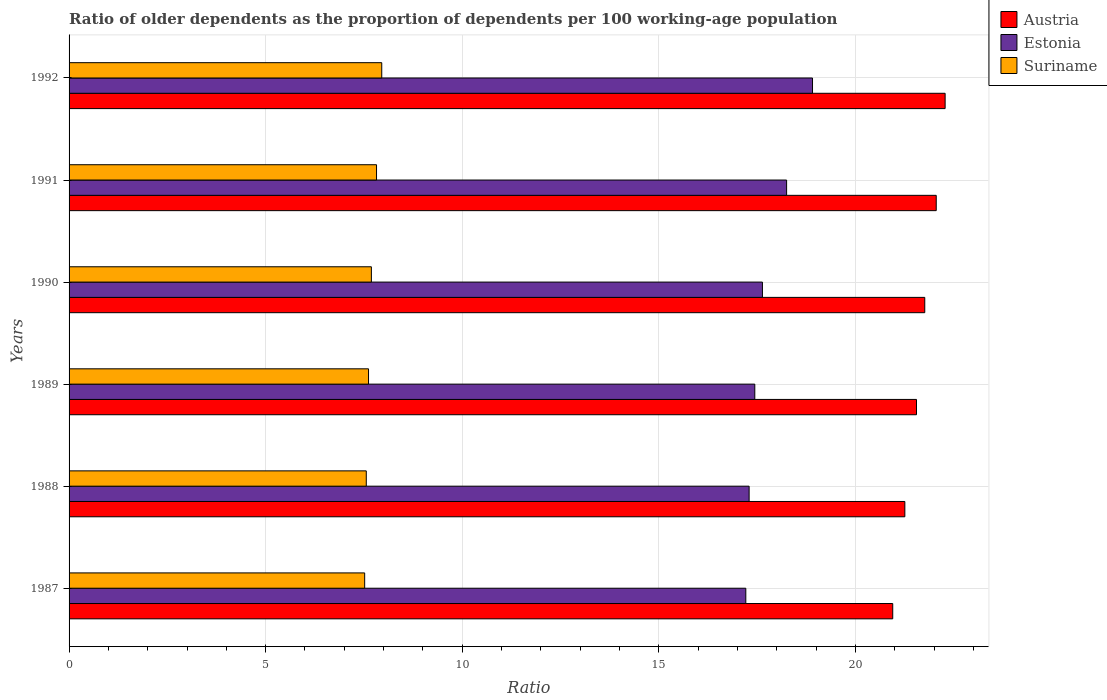How many different coloured bars are there?
Provide a short and direct response. 3. How many groups of bars are there?
Offer a terse response. 6. Are the number of bars per tick equal to the number of legend labels?
Ensure brevity in your answer.  Yes. How many bars are there on the 1st tick from the bottom?
Provide a short and direct response. 3. What is the label of the 1st group of bars from the top?
Make the answer very short. 1992. What is the age dependency ratio(old) in Suriname in 1989?
Ensure brevity in your answer.  7.62. Across all years, what is the maximum age dependency ratio(old) in Suriname?
Provide a succinct answer. 7.95. Across all years, what is the minimum age dependency ratio(old) in Estonia?
Keep it short and to the point. 17.21. What is the total age dependency ratio(old) in Estonia in the graph?
Your answer should be very brief. 106.75. What is the difference between the age dependency ratio(old) in Suriname in 1988 and that in 1991?
Keep it short and to the point. -0.26. What is the difference between the age dependency ratio(old) in Austria in 1988 and the age dependency ratio(old) in Estonia in 1991?
Offer a very short reply. 3.01. What is the average age dependency ratio(old) in Austria per year?
Your answer should be compact. 21.64. In the year 1991, what is the difference between the age dependency ratio(old) in Estonia and age dependency ratio(old) in Austria?
Keep it short and to the point. -3.81. In how many years, is the age dependency ratio(old) in Austria greater than 22 ?
Your answer should be compact. 2. What is the ratio of the age dependency ratio(old) in Suriname in 1991 to that in 1992?
Your answer should be compact. 0.98. Is the age dependency ratio(old) in Austria in 1987 less than that in 1988?
Keep it short and to the point. Yes. Is the difference between the age dependency ratio(old) in Estonia in 1987 and 1990 greater than the difference between the age dependency ratio(old) in Austria in 1987 and 1990?
Offer a very short reply. Yes. What is the difference between the highest and the second highest age dependency ratio(old) in Austria?
Your answer should be very brief. 0.23. What is the difference between the highest and the lowest age dependency ratio(old) in Estonia?
Offer a terse response. 1.7. Is the sum of the age dependency ratio(old) in Suriname in 1987 and 1988 greater than the maximum age dependency ratio(old) in Estonia across all years?
Your answer should be compact. No. What does the 1st bar from the top in 1987 represents?
Make the answer very short. Suriname. What does the 2nd bar from the bottom in 1989 represents?
Offer a terse response. Estonia. What is the difference between two consecutive major ticks on the X-axis?
Offer a terse response. 5. Are the values on the major ticks of X-axis written in scientific E-notation?
Make the answer very short. No. Does the graph contain grids?
Keep it short and to the point. Yes. How many legend labels are there?
Provide a short and direct response. 3. How are the legend labels stacked?
Your response must be concise. Vertical. What is the title of the graph?
Keep it short and to the point. Ratio of older dependents as the proportion of dependents per 100 working-age population. Does "Cayman Islands" appear as one of the legend labels in the graph?
Your response must be concise. No. What is the label or title of the X-axis?
Provide a short and direct response. Ratio. What is the Ratio of Austria in 1987?
Your answer should be very brief. 20.95. What is the Ratio in Estonia in 1987?
Provide a short and direct response. 17.21. What is the Ratio of Suriname in 1987?
Your answer should be very brief. 7.52. What is the Ratio of Austria in 1988?
Keep it short and to the point. 21.26. What is the Ratio in Estonia in 1988?
Offer a terse response. 17.3. What is the Ratio in Suriname in 1988?
Give a very brief answer. 7.56. What is the Ratio in Austria in 1989?
Give a very brief answer. 21.55. What is the Ratio in Estonia in 1989?
Make the answer very short. 17.44. What is the Ratio of Suriname in 1989?
Give a very brief answer. 7.62. What is the Ratio of Austria in 1990?
Provide a succinct answer. 21.76. What is the Ratio in Estonia in 1990?
Provide a succinct answer. 17.64. What is the Ratio of Suriname in 1990?
Offer a very short reply. 7.69. What is the Ratio in Austria in 1991?
Provide a short and direct response. 22.06. What is the Ratio of Estonia in 1991?
Provide a succinct answer. 18.25. What is the Ratio of Suriname in 1991?
Ensure brevity in your answer.  7.82. What is the Ratio of Austria in 1992?
Your response must be concise. 22.28. What is the Ratio in Estonia in 1992?
Provide a succinct answer. 18.91. What is the Ratio in Suriname in 1992?
Offer a terse response. 7.95. Across all years, what is the maximum Ratio in Austria?
Keep it short and to the point. 22.28. Across all years, what is the maximum Ratio in Estonia?
Make the answer very short. 18.91. Across all years, what is the maximum Ratio in Suriname?
Keep it short and to the point. 7.95. Across all years, what is the minimum Ratio of Austria?
Offer a very short reply. 20.95. Across all years, what is the minimum Ratio of Estonia?
Provide a short and direct response. 17.21. Across all years, what is the minimum Ratio of Suriname?
Your answer should be very brief. 7.52. What is the total Ratio of Austria in the graph?
Provide a succinct answer. 129.87. What is the total Ratio in Estonia in the graph?
Keep it short and to the point. 106.75. What is the total Ratio in Suriname in the graph?
Your answer should be very brief. 46.16. What is the difference between the Ratio of Austria in 1987 and that in 1988?
Make the answer very short. -0.31. What is the difference between the Ratio in Estonia in 1987 and that in 1988?
Make the answer very short. -0.08. What is the difference between the Ratio of Suriname in 1987 and that in 1988?
Offer a terse response. -0.04. What is the difference between the Ratio in Austria in 1987 and that in 1989?
Provide a short and direct response. -0.6. What is the difference between the Ratio in Estonia in 1987 and that in 1989?
Make the answer very short. -0.23. What is the difference between the Ratio of Suriname in 1987 and that in 1989?
Offer a terse response. -0.1. What is the difference between the Ratio in Austria in 1987 and that in 1990?
Ensure brevity in your answer.  -0.81. What is the difference between the Ratio in Estonia in 1987 and that in 1990?
Your answer should be very brief. -0.42. What is the difference between the Ratio in Suriname in 1987 and that in 1990?
Offer a very short reply. -0.17. What is the difference between the Ratio of Austria in 1987 and that in 1991?
Your answer should be compact. -1.11. What is the difference between the Ratio in Estonia in 1987 and that in 1991?
Provide a short and direct response. -1.04. What is the difference between the Ratio in Suriname in 1987 and that in 1991?
Offer a terse response. -0.3. What is the difference between the Ratio in Austria in 1987 and that in 1992?
Make the answer very short. -1.33. What is the difference between the Ratio in Estonia in 1987 and that in 1992?
Ensure brevity in your answer.  -1.7. What is the difference between the Ratio in Suriname in 1987 and that in 1992?
Your answer should be very brief. -0.43. What is the difference between the Ratio of Austria in 1988 and that in 1989?
Make the answer very short. -0.3. What is the difference between the Ratio in Estonia in 1988 and that in 1989?
Keep it short and to the point. -0.14. What is the difference between the Ratio in Suriname in 1988 and that in 1989?
Your answer should be very brief. -0.06. What is the difference between the Ratio of Austria in 1988 and that in 1990?
Keep it short and to the point. -0.51. What is the difference between the Ratio of Estonia in 1988 and that in 1990?
Offer a terse response. -0.34. What is the difference between the Ratio of Suriname in 1988 and that in 1990?
Your answer should be very brief. -0.13. What is the difference between the Ratio of Austria in 1988 and that in 1991?
Make the answer very short. -0.8. What is the difference between the Ratio of Estonia in 1988 and that in 1991?
Offer a very short reply. -0.95. What is the difference between the Ratio of Suriname in 1988 and that in 1991?
Make the answer very short. -0.26. What is the difference between the Ratio of Austria in 1988 and that in 1992?
Give a very brief answer. -1.02. What is the difference between the Ratio in Estonia in 1988 and that in 1992?
Provide a succinct answer. -1.61. What is the difference between the Ratio of Suriname in 1988 and that in 1992?
Your response must be concise. -0.39. What is the difference between the Ratio in Austria in 1989 and that in 1990?
Keep it short and to the point. -0.21. What is the difference between the Ratio of Estonia in 1989 and that in 1990?
Your answer should be compact. -0.19. What is the difference between the Ratio in Suriname in 1989 and that in 1990?
Provide a short and direct response. -0.07. What is the difference between the Ratio of Austria in 1989 and that in 1991?
Ensure brevity in your answer.  -0.5. What is the difference between the Ratio of Estonia in 1989 and that in 1991?
Your response must be concise. -0.81. What is the difference between the Ratio in Suriname in 1989 and that in 1991?
Make the answer very short. -0.2. What is the difference between the Ratio in Austria in 1989 and that in 1992?
Provide a succinct answer. -0.73. What is the difference between the Ratio of Estonia in 1989 and that in 1992?
Your response must be concise. -1.47. What is the difference between the Ratio of Suriname in 1989 and that in 1992?
Keep it short and to the point. -0.34. What is the difference between the Ratio in Austria in 1990 and that in 1991?
Your answer should be very brief. -0.29. What is the difference between the Ratio of Estonia in 1990 and that in 1991?
Your answer should be compact. -0.61. What is the difference between the Ratio in Suriname in 1990 and that in 1991?
Ensure brevity in your answer.  -0.13. What is the difference between the Ratio in Austria in 1990 and that in 1992?
Your answer should be very brief. -0.52. What is the difference between the Ratio in Estonia in 1990 and that in 1992?
Offer a terse response. -1.27. What is the difference between the Ratio of Suriname in 1990 and that in 1992?
Your answer should be very brief. -0.26. What is the difference between the Ratio in Austria in 1991 and that in 1992?
Your answer should be compact. -0.23. What is the difference between the Ratio of Estonia in 1991 and that in 1992?
Your answer should be very brief. -0.66. What is the difference between the Ratio in Suriname in 1991 and that in 1992?
Make the answer very short. -0.13. What is the difference between the Ratio in Austria in 1987 and the Ratio in Estonia in 1988?
Offer a terse response. 3.65. What is the difference between the Ratio in Austria in 1987 and the Ratio in Suriname in 1988?
Provide a short and direct response. 13.39. What is the difference between the Ratio of Estonia in 1987 and the Ratio of Suriname in 1988?
Your answer should be very brief. 9.65. What is the difference between the Ratio in Austria in 1987 and the Ratio in Estonia in 1989?
Provide a short and direct response. 3.51. What is the difference between the Ratio in Austria in 1987 and the Ratio in Suriname in 1989?
Offer a terse response. 13.33. What is the difference between the Ratio of Estonia in 1987 and the Ratio of Suriname in 1989?
Ensure brevity in your answer.  9.6. What is the difference between the Ratio of Austria in 1987 and the Ratio of Estonia in 1990?
Your answer should be very brief. 3.31. What is the difference between the Ratio in Austria in 1987 and the Ratio in Suriname in 1990?
Ensure brevity in your answer.  13.26. What is the difference between the Ratio of Estonia in 1987 and the Ratio of Suriname in 1990?
Provide a short and direct response. 9.52. What is the difference between the Ratio of Austria in 1987 and the Ratio of Estonia in 1991?
Make the answer very short. 2.7. What is the difference between the Ratio of Austria in 1987 and the Ratio of Suriname in 1991?
Offer a terse response. 13.13. What is the difference between the Ratio in Estonia in 1987 and the Ratio in Suriname in 1991?
Ensure brevity in your answer.  9.39. What is the difference between the Ratio of Austria in 1987 and the Ratio of Estonia in 1992?
Your answer should be very brief. 2.04. What is the difference between the Ratio in Austria in 1987 and the Ratio in Suriname in 1992?
Offer a terse response. 13. What is the difference between the Ratio in Estonia in 1987 and the Ratio in Suriname in 1992?
Provide a short and direct response. 9.26. What is the difference between the Ratio in Austria in 1988 and the Ratio in Estonia in 1989?
Your answer should be very brief. 3.82. What is the difference between the Ratio of Austria in 1988 and the Ratio of Suriname in 1989?
Keep it short and to the point. 13.64. What is the difference between the Ratio of Estonia in 1988 and the Ratio of Suriname in 1989?
Offer a very short reply. 9.68. What is the difference between the Ratio of Austria in 1988 and the Ratio of Estonia in 1990?
Offer a very short reply. 3.62. What is the difference between the Ratio in Austria in 1988 and the Ratio in Suriname in 1990?
Your response must be concise. 13.57. What is the difference between the Ratio of Estonia in 1988 and the Ratio of Suriname in 1990?
Give a very brief answer. 9.61. What is the difference between the Ratio in Austria in 1988 and the Ratio in Estonia in 1991?
Offer a very short reply. 3.01. What is the difference between the Ratio in Austria in 1988 and the Ratio in Suriname in 1991?
Ensure brevity in your answer.  13.44. What is the difference between the Ratio of Estonia in 1988 and the Ratio of Suriname in 1991?
Keep it short and to the point. 9.48. What is the difference between the Ratio of Austria in 1988 and the Ratio of Estonia in 1992?
Make the answer very short. 2.35. What is the difference between the Ratio of Austria in 1988 and the Ratio of Suriname in 1992?
Give a very brief answer. 13.3. What is the difference between the Ratio in Estonia in 1988 and the Ratio in Suriname in 1992?
Your response must be concise. 9.34. What is the difference between the Ratio in Austria in 1989 and the Ratio in Estonia in 1990?
Offer a very short reply. 3.92. What is the difference between the Ratio in Austria in 1989 and the Ratio in Suriname in 1990?
Offer a terse response. 13.87. What is the difference between the Ratio in Estonia in 1989 and the Ratio in Suriname in 1990?
Provide a short and direct response. 9.75. What is the difference between the Ratio in Austria in 1989 and the Ratio in Estonia in 1991?
Offer a terse response. 3.3. What is the difference between the Ratio of Austria in 1989 and the Ratio of Suriname in 1991?
Ensure brevity in your answer.  13.73. What is the difference between the Ratio of Estonia in 1989 and the Ratio of Suriname in 1991?
Offer a very short reply. 9.62. What is the difference between the Ratio in Austria in 1989 and the Ratio in Estonia in 1992?
Provide a short and direct response. 2.64. What is the difference between the Ratio in Austria in 1989 and the Ratio in Suriname in 1992?
Make the answer very short. 13.6. What is the difference between the Ratio in Estonia in 1989 and the Ratio in Suriname in 1992?
Provide a short and direct response. 9.49. What is the difference between the Ratio in Austria in 1990 and the Ratio in Estonia in 1991?
Ensure brevity in your answer.  3.51. What is the difference between the Ratio of Austria in 1990 and the Ratio of Suriname in 1991?
Provide a short and direct response. 13.94. What is the difference between the Ratio of Estonia in 1990 and the Ratio of Suriname in 1991?
Keep it short and to the point. 9.82. What is the difference between the Ratio in Austria in 1990 and the Ratio in Estonia in 1992?
Your response must be concise. 2.85. What is the difference between the Ratio of Austria in 1990 and the Ratio of Suriname in 1992?
Offer a terse response. 13.81. What is the difference between the Ratio in Estonia in 1990 and the Ratio in Suriname in 1992?
Your response must be concise. 9.68. What is the difference between the Ratio in Austria in 1991 and the Ratio in Estonia in 1992?
Offer a terse response. 3.15. What is the difference between the Ratio of Austria in 1991 and the Ratio of Suriname in 1992?
Make the answer very short. 14.1. What is the difference between the Ratio of Estonia in 1991 and the Ratio of Suriname in 1992?
Offer a very short reply. 10.3. What is the average Ratio of Austria per year?
Offer a very short reply. 21.64. What is the average Ratio in Estonia per year?
Give a very brief answer. 17.79. What is the average Ratio of Suriname per year?
Offer a terse response. 7.69. In the year 1987, what is the difference between the Ratio in Austria and Ratio in Estonia?
Your answer should be compact. 3.74. In the year 1987, what is the difference between the Ratio of Austria and Ratio of Suriname?
Keep it short and to the point. 13.43. In the year 1987, what is the difference between the Ratio in Estonia and Ratio in Suriname?
Provide a succinct answer. 9.69. In the year 1988, what is the difference between the Ratio of Austria and Ratio of Estonia?
Offer a terse response. 3.96. In the year 1988, what is the difference between the Ratio in Austria and Ratio in Suriname?
Your answer should be compact. 13.7. In the year 1988, what is the difference between the Ratio of Estonia and Ratio of Suriname?
Make the answer very short. 9.74. In the year 1989, what is the difference between the Ratio of Austria and Ratio of Estonia?
Provide a short and direct response. 4.11. In the year 1989, what is the difference between the Ratio of Austria and Ratio of Suriname?
Offer a terse response. 13.94. In the year 1989, what is the difference between the Ratio of Estonia and Ratio of Suriname?
Ensure brevity in your answer.  9.82. In the year 1990, what is the difference between the Ratio in Austria and Ratio in Estonia?
Offer a terse response. 4.13. In the year 1990, what is the difference between the Ratio in Austria and Ratio in Suriname?
Offer a very short reply. 14.08. In the year 1990, what is the difference between the Ratio of Estonia and Ratio of Suriname?
Give a very brief answer. 9.95. In the year 1991, what is the difference between the Ratio in Austria and Ratio in Estonia?
Provide a short and direct response. 3.81. In the year 1991, what is the difference between the Ratio in Austria and Ratio in Suriname?
Offer a terse response. 14.24. In the year 1991, what is the difference between the Ratio of Estonia and Ratio of Suriname?
Keep it short and to the point. 10.43. In the year 1992, what is the difference between the Ratio of Austria and Ratio of Estonia?
Offer a very short reply. 3.37. In the year 1992, what is the difference between the Ratio in Austria and Ratio in Suriname?
Make the answer very short. 14.33. In the year 1992, what is the difference between the Ratio in Estonia and Ratio in Suriname?
Provide a succinct answer. 10.96. What is the ratio of the Ratio of Austria in 1987 to that in 1988?
Offer a very short reply. 0.99. What is the ratio of the Ratio in Estonia in 1987 to that in 1988?
Provide a succinct answer. 1. What is the ratio of the Ratio of Suriname in 1987 to that in 1988?
Ensure brevity in your answer.  0.99. What is the ratio of the Ratio of Austria in 1987 to that in 1989?
Provide a succinct answer. 0.97. What is the ratio of the Ratio in Estonia in 1987 to that in 1989?
Your answer should be very brief. 0.99. What is the ratio of the Ratio of Suriname in 1987 to that in 1989?
Your answer should be very brief. 0.99. What is the ratio of the Ratio in Austria in 1987 to that in 1990?
Provide a succinct answer. 0.96. What is the ratio of the Ratio in Estonia in 1987 to that in 1990?
Provide a short and direct response. 0.98. What is the ratio of the Ratio of Suriname in 1987 to that in 1990?
Give a very brief answer. 0.98. What is the ratio of the Ratio in Austria in 1987 to that in 1991?
Your answer should be compact. 0.95. What is the ratio of the Ratio of Estonia in 1987 to that in 1991?
Your response must be concise. 0.94. What is the ratio of the Ratio in Suriname in 1987 to that in 1991?
Your answer should be very brief. 0.96. What is the ratio of the Ratio in Austria in 1987 to that in 1992?
Provide a short and direct response. 0.94. What is the ratio of the Ratio of Estonia in 1987 to that in 1992?
Offer a terse response. 0.91. What is the ratio of the Ratio of Suriname in 1987 to that in 1992?
Offer a very short reply. 0.95. What is the ratio of the Ratio of Austria in 1988 to that in 1989?
Give a very brief answer. 0.99. What is the ratio of the Ratio in Suriname in 1988 to that in 1989?
Your response must be concise. 0.99. What is the ratio of the Ratio of Austria in 1988 to that in 1990?
Offer a very short reply. 0.98. What is the ratio of the Ratio of Estonia in 1988 to that in 1990?
Your answer should be very brief. 0.98. What is the ratio of the Ratio of Suriname in 1988 to that in 1990?
Make the answer very short. 0.98. What is the ratio of the Ratio of Austria in 1988 to that in 1991?
Keep it short and to the point. 0.96. What is the ratio of the Ratio in Estonia in 1988 to that in 1991?
Offer a very short reply. 0.95. What is the ratio of the Ratio of Suriname in 1988 to that in 1991?
Make the answer very short. 0.97. What is the ratio of the Ratio in Austria in 1988 to that in 1992?
Ensure brevity in your answer.  0.95. What is the ratio of the Ratio in Estonia in 1988 to that in 1992?
Provide a succinct answer. 0.91. What is the ratio of the Ratio of Suriname in 1988 to that in 1992?
Ensure brevity in your answer.  0.95. What is the ratio of the Ratio in Austria in 1989 to that in 1990?
Your answer should be compact. 0.99. What is the ratio of the Ratio in Estonia in 1989 to that in 1990?
Offer a very short reply. 0.99. What is the ratio of the Ratio in Suriname in 1989 to that in 1990?
Offer a terse response. 0.99. What is the ratio of the Ratio of Austria in 1989 to that in 1991?
Offer a very short reply. 0.98. What is the ratio of the Ratio of Estonia in 1989 to that in 1991?
Your answer should be compact. 0.96. What is the ratio of the Ratio in Austria in 1989 to that in 1992?
Offer a terse response. 0.97. What is the ratio of the Ratio in Estonia in 1989 to that in 1992?
Offer a terse response. 0.92. What is the ratio of the Ratio of Suriname in 1989 to that in 1992?
Make the answer very short. 0.96. What is the ratio of the Ratio in Estonia in 1990 to that in 1991?
Make the answer very short. 0.97. What is the ratio of the Ratio in Suriname in 1990 to that in 1991?
Make the answer very short. 0.98. What is the ratio of the Ratio of Austria in 1990 to that in 1992?
Provide a short and direct response. 0.98. What is the ratio of the Ratio of Estonia in 1990 to that in 1992?
Provide a short and direct response. 0.93. What is the ratio of the Ratio in Suriname in 1990 to that in 1992?
Your answer should be very brief. 0.97. What is the ratio of the Ratio of Austria in 1991 to that in 1992?
Your answer should be very brief. 0.99. What is the ratio of the Ratio in Estonia in 1991 to that in 1992?
Provide a short and direct response. 0.97. What is the ratio of the Ratio of Suriname in 1991 to that in 1992?
Your answer should be very brief. 0.98. What is the difference between the highest and the second highest Ratio of Austria?
Ensure brevity in your answer.  0.23. What is the difference between the highest and the second highest Ratio in Estonia?
Offer a very short reply. 0.66. What is the difference between the highest and the second highest Ratio in Suriname?
Give a very brief answer. 0.13. What is the difference between the highest and the lowest Ratio in Austria?
Provide a short and direct response. 1.33. What is the difference between the highest and the lowest Ratio in Estonia?
Provide a succinct answer. 1.7. What is the difference between the highest and the lowest Ratio of Suriname?
Provide a succinct answer. 0.43. 